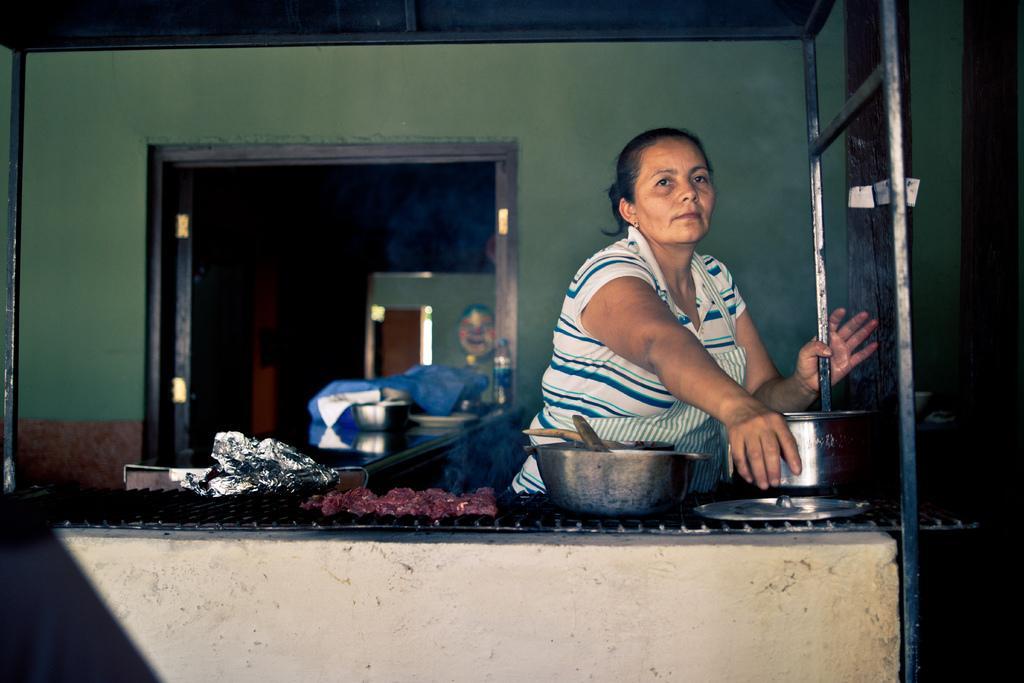Describe this image in one or two sentences. As we can see in the image there is wall, door, a woman wearing white color dress, dish and there are bowls. 